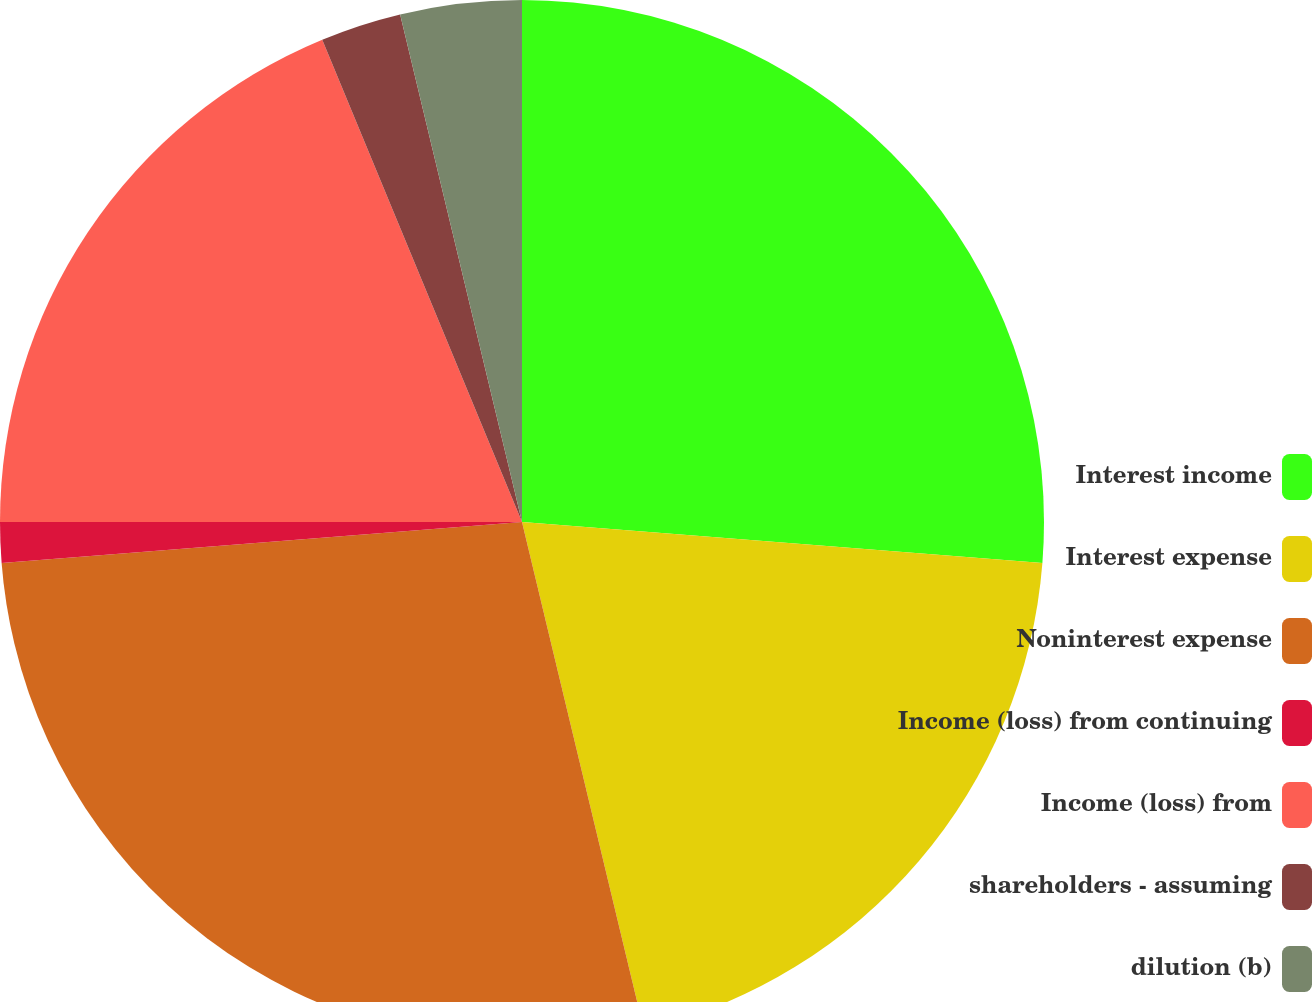Convert chart to OTSL. <chart><loc_0><loc_0><loc_500><loc_500><pie_chart><fcel>Interest income<fcel>Interest expense<fcel>Noninterest expense<fcel>Income (loss) from continuing<fcel>Income (loss) from<fcel>shareholders - assuming<fcel>dilution (b)<nl><fcel>26.25%<fcel>20.0%<fcel>27.5%<fcel>1.25%<fcel>18.75%<fcel>2.5%<fcel>3.75%<nl></chart> 